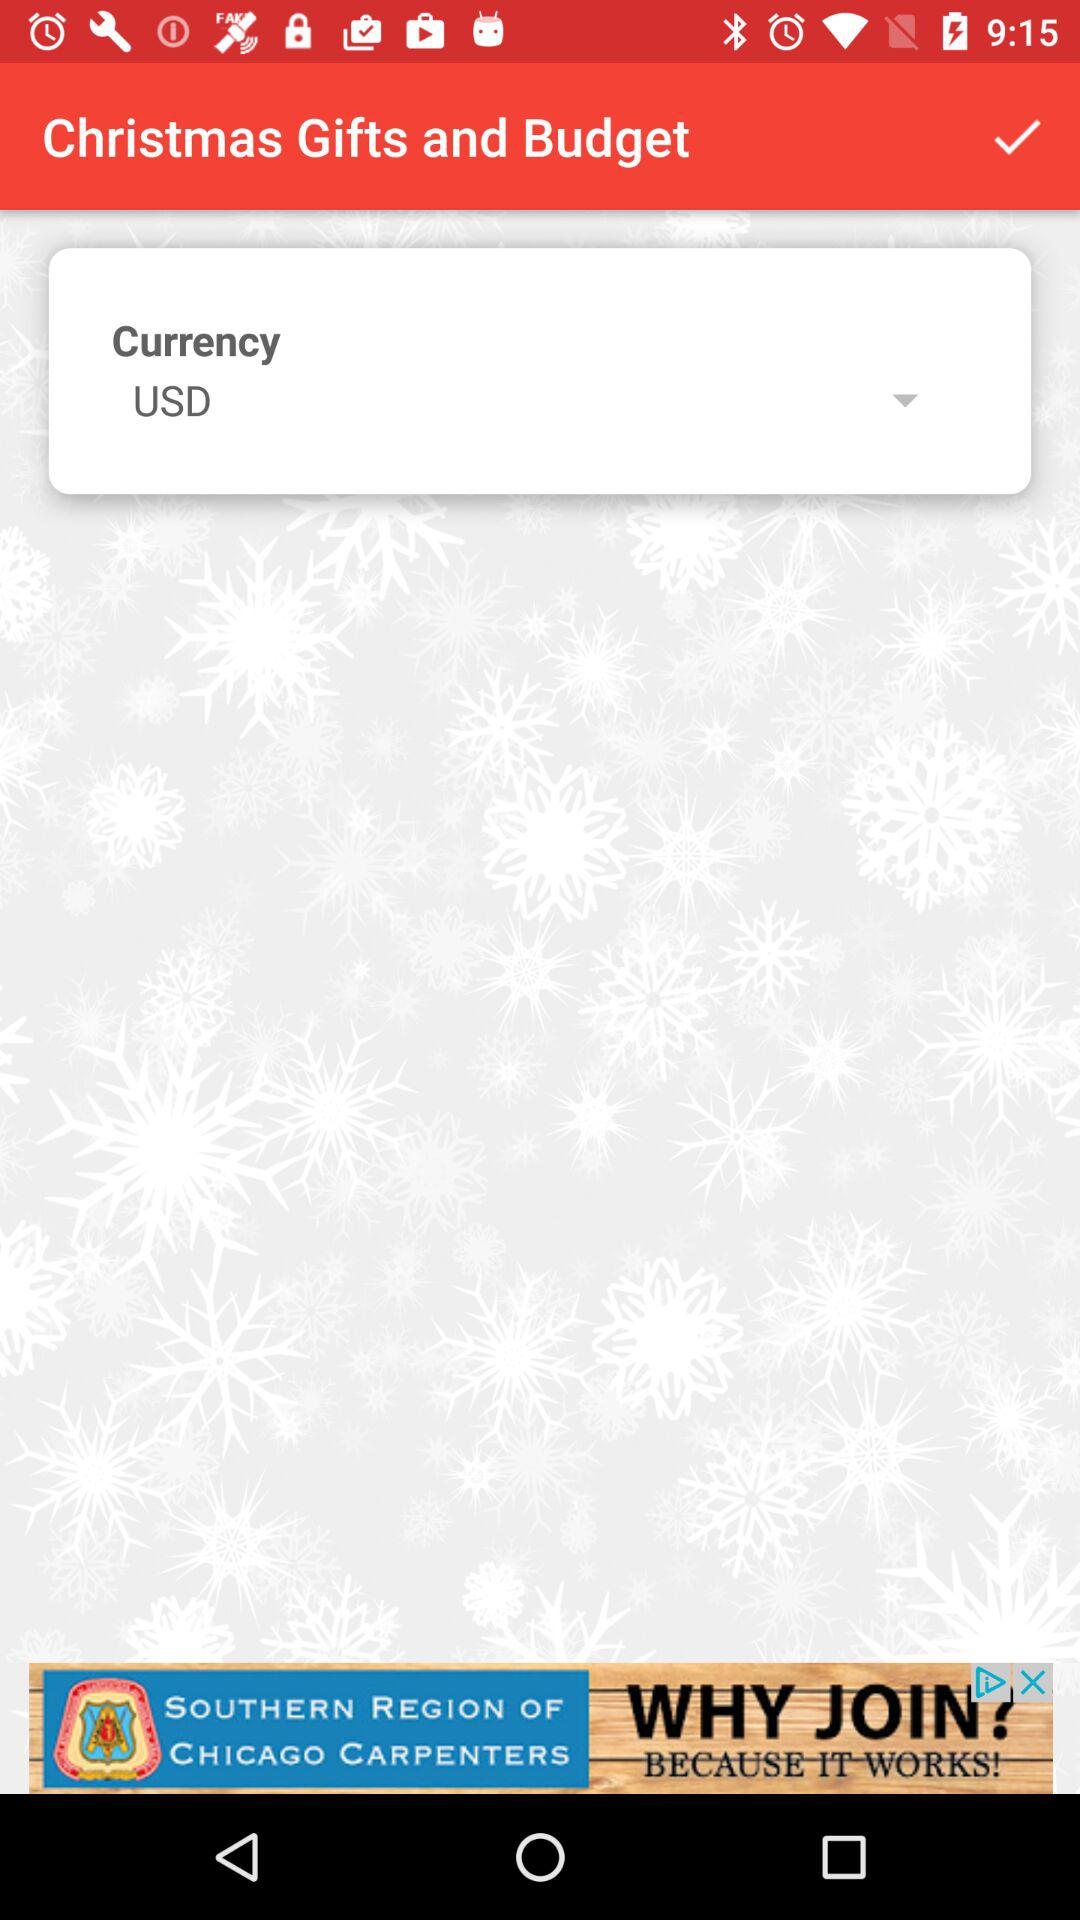What is the currency? The currency is USD. 